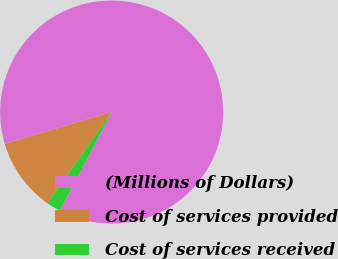Convert chart to OTSL. <chart><loc_0><loc_0><loc_500><loc_500><pie_chart><fcel>(Millions of Dollars)<fcel>Cost of services provided<fcel>Cost of services received<nl><fcel>87.31%<fcel>10.61%<fcel>2.08%<nl></chart> 